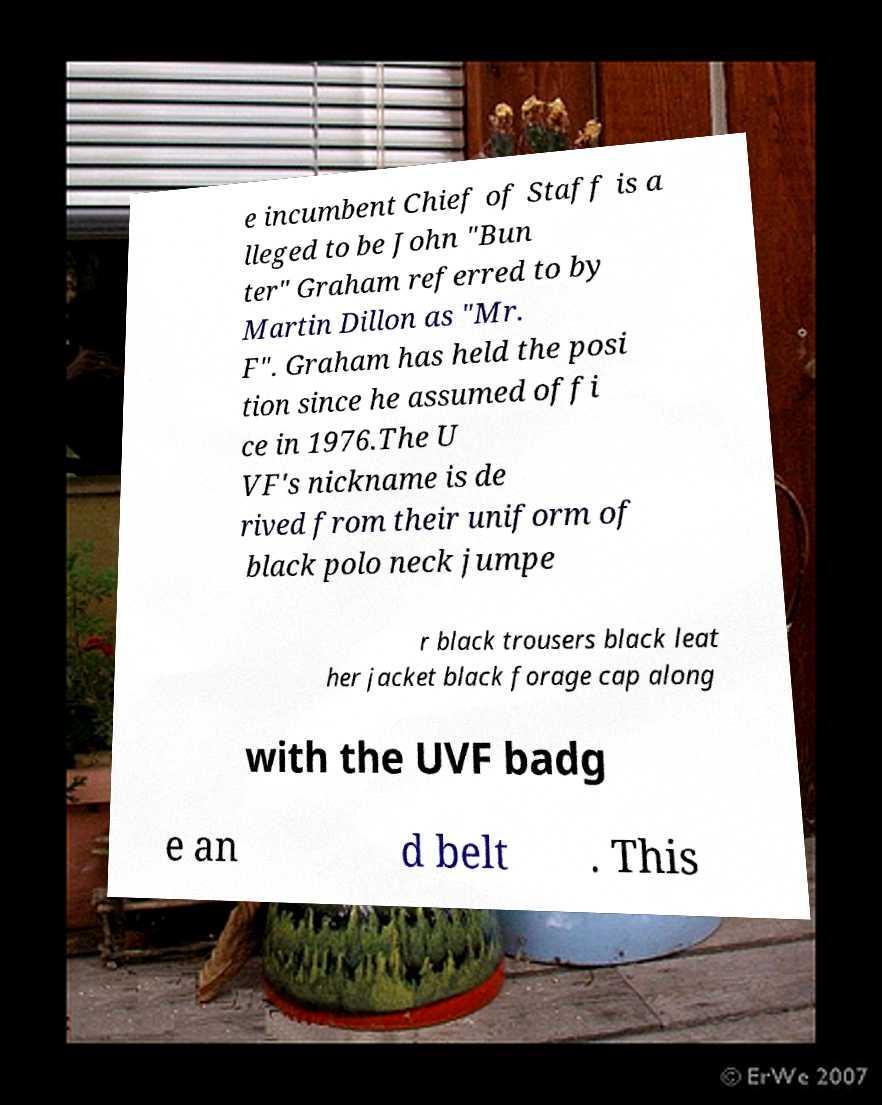Could you extract and type out the text from this image? e incumbent Chief of Staff is a lleged to be John "Bun ter" Graham referred to by Martin Dillon as "Mr. F". Graham has held the posi tion since he assumed offi ce in 1976.The U VF's nickname is de rived from their uniform of black polo neck jumpe r black trousers black leat her jacket black forage cap along with the UVF badg e an d belt . This 